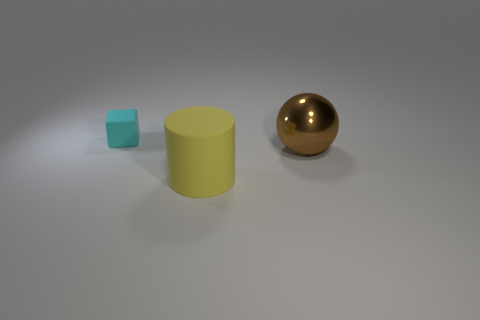Add 1 cyan rubber cubes. How many objects exist? 4 Subtract all spheres. How many objects are left? 2 Subtract all large cyan matte cylinders. Subtract all yellow rubber things. How many objects are left? 2 Add 3 small objects. How many small objects are left? 4 Add 3 rubber cubes. How many rubber cubes exist? 4 Subtract 0 purple cubes. How many objects are left? 3 